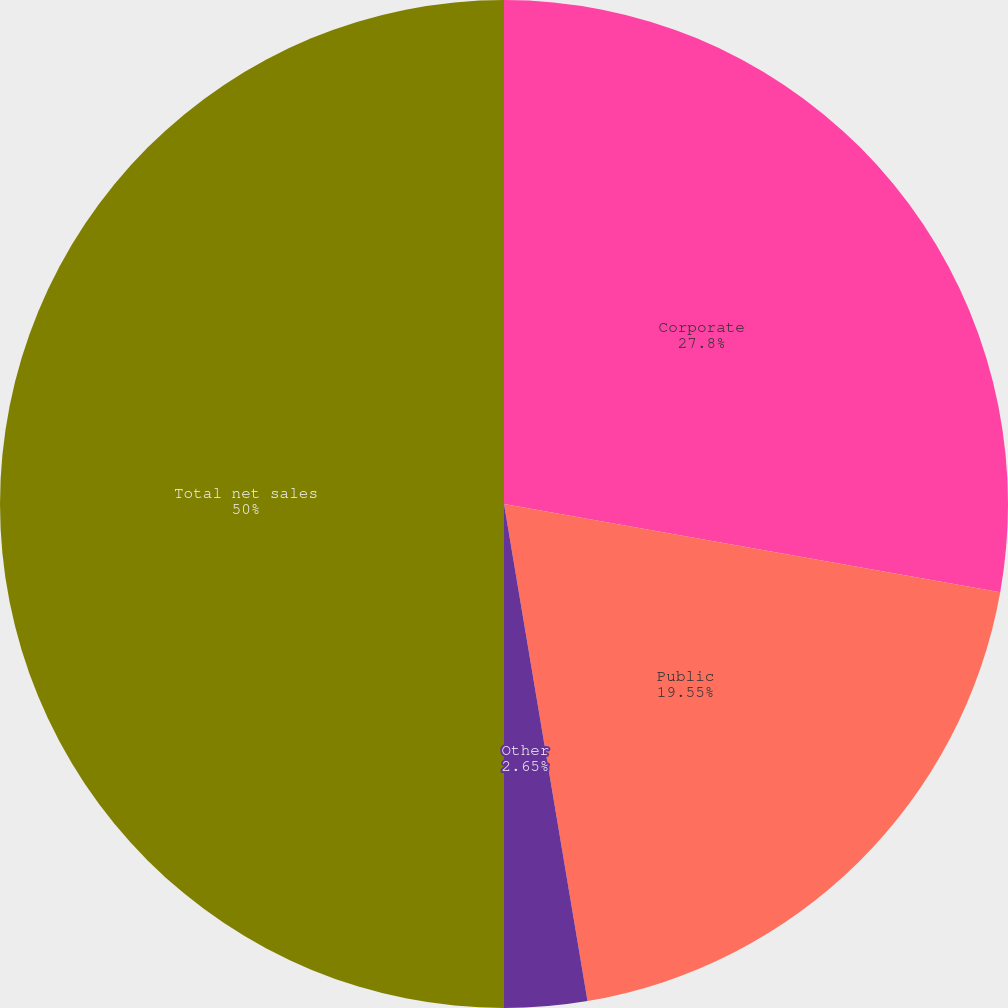Convert chart. <chart><loc_0><loc_0><loc_500><loc_500><pie_chart><fcel>Corporate<fcel>Public<fcel>Other<fcel>Total net sales<nl><fcel>27.8%<fcel>19.55%<fcel>2.65%<fcel>50.0%<nl></chart> 